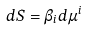<formula> <loc_0><loc_0><loc_500><loc_500>d S = \beta _ { i } d \mu ^ { i }</formula> 